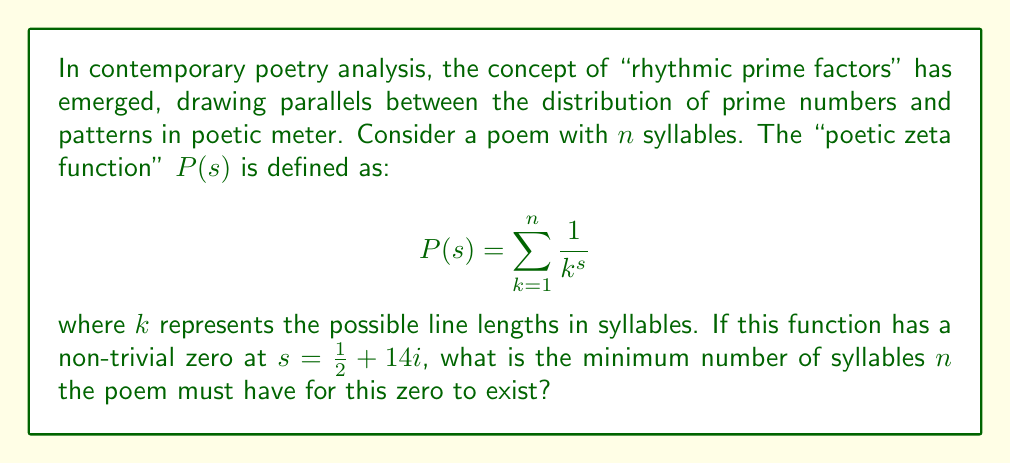Give your solution to this math problem. To solve this problem, we need to understand the connection between the Riemann zeta function and our "poetic zeta function" $P(s)$. The key is recognizing that $P(s)$ is a truncated version of the Riemann zeta function.

1) First, recall that the Riemann zeta function is defined as:

   $$\zeta(s) = \sum_{k=1}^{\infty} \frac{1}{k^s}$$

2) Our $P(s)$ is the same sum, but only up to $n$ instead of infinity.

3) For $P(s)$ to have a zero at $s = \frac{1}{2} + 14i$, it must closely approximate the Riemann zeta function up to this point on the critical line.

4) We can estimate how large $n$ needs to be by considering the magnitude of the terms in the series at this point:

   $$\left|\frac{1}{k^{(\frac{1}{2} + 14i)}}\right| = \frac{1}{k^{\frac{1}{2}}}$$

5) We want the terms beyond $n$ to be negligibly small. A common rule of thumb is to include terms until they're smaller than $10^{-6}$.

6) So, we need to find $n$ such that:

   $$\frac{1}{n^{\frac{1}{2}}} < 10^{-6}$$

7) Solving this inequality:

   $$n^{\frac{1}{2}} > 10^6$$
   $$n > 10^{12}$$

8) Therefore, the minimum integer $n$ that satisfies this is $n = 1,000,000,000,001$.

This enormous number reflects the fact that the Riemann zeta function's non-trivial zeros occur very high up on the critical line, requiring a vast number of terms to approximate accurately.
Answer: The minimum number of syllables $n$ the poem must have is 1,000,000,000,001. 